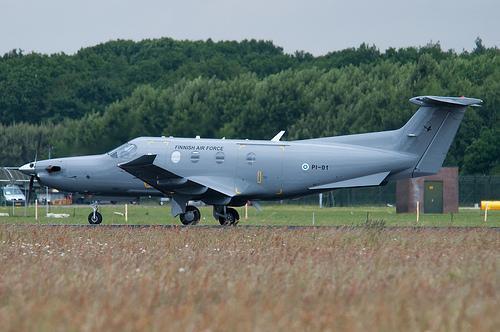How many planes are there?
Give a very brief answer. 1. 